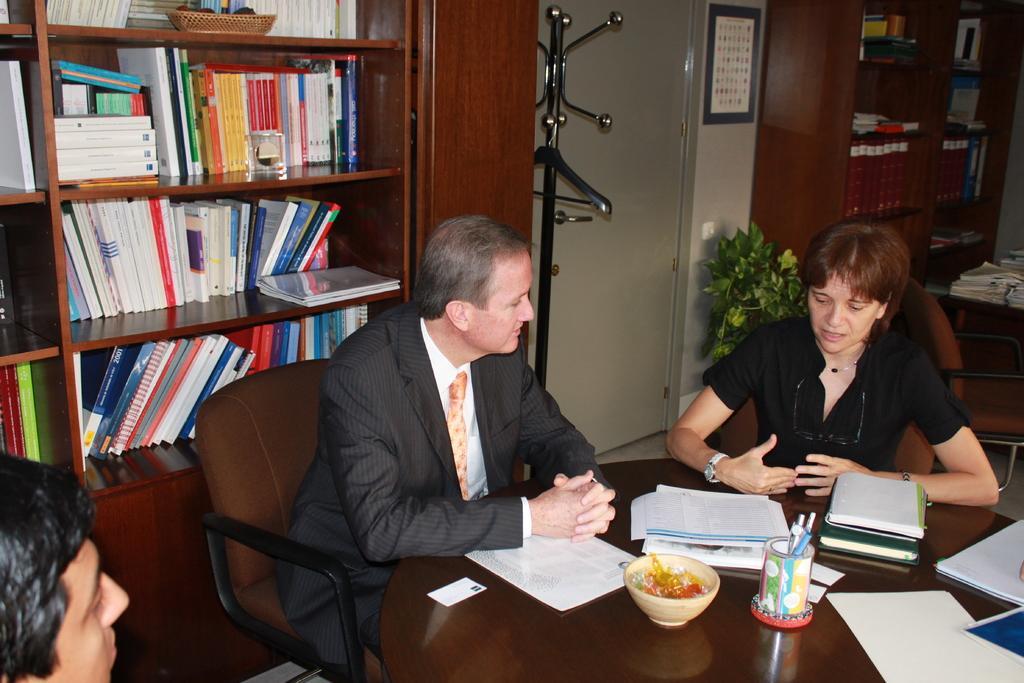How would you summarize this image in a sentence or two? This picture shows couple of men and a woman seated on the chairs and we see papers, books and pen stand and a bowl on the table and we see couple of bookshelves with books and another table with books on it and we see photo frame on the wall and a plant. 